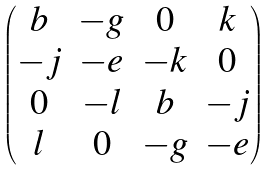Convert formula to latex. <formula><loc_0><loc_0><loc_500><loc_500>\begin{pmatrix} b & - g & 0 & k \\ - j & - e & - k & 0 \\ 0 & - l & b & - j \\ l & 0 & - g & - e \end{pmatrix}</formula> 